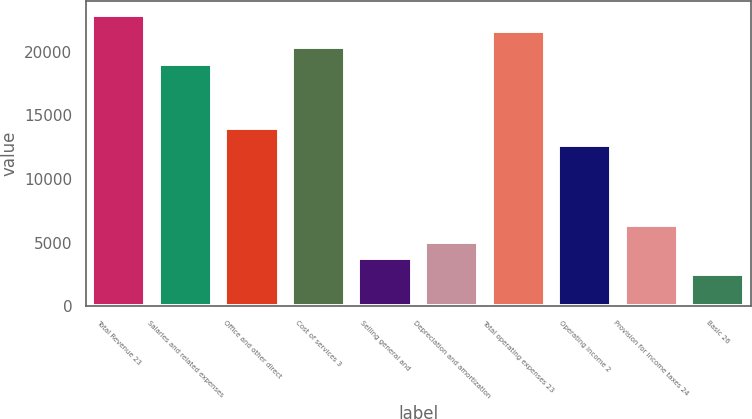<chart> <loc_0><loc_0><loc_500><loc_500><bar_chart><fcel>Total Revenue 23<fcel>Salaries and related expenses<fcel>Office and other direct<fcel>Cost of services 3<fcel>Selling general and<fcel>Depreciation and amortization<fcel>Total operating expenses 23<fcel>Operating income 2<fcel>Provision for income taxes 24<fcel>Basic 26<nl><fcel>22867.9<fcel>19056.7<fcel>13975.1<fcel>20327.1<fcel>3811.92<fcel>5082.32<fcel>21597.5<fcel>12704.7<fcel>6352.72<fcel>2541.52<nl></chart> 